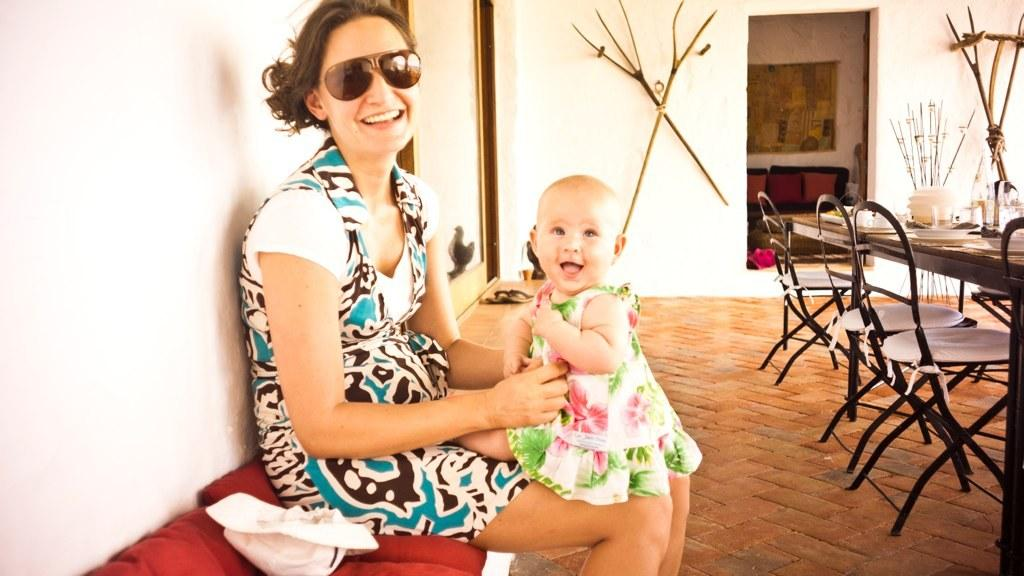Who is the main subject in the image? There is a woman in the image. What is the woman wearing? The woman is wearing a blue dress and black goggles. Are there any other people in the image? Yes, there is a kid in the image. What can be seen on the right side of the image? There is a dining table on the right side of the image. What type of worm can be seen crawling on the woman's blue dress in the image? There is no worm present on the woman's blue dress in the image. 